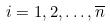<formula> <loc_0><loc_0><loc_500><loc_500>i = 1 , 2 , \dots , \overline { n }</formula> 